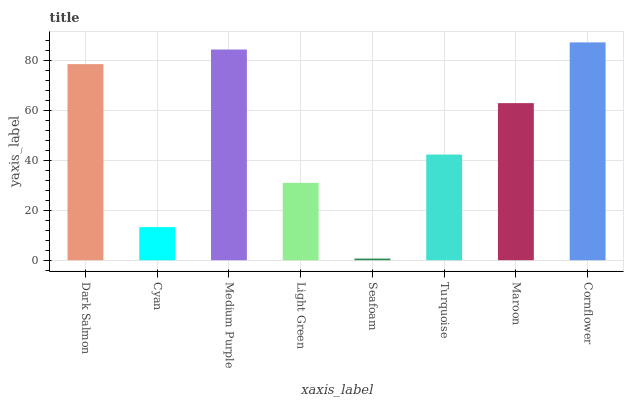Is Seafoam the minimum?
Answer yes or no. Yes. Is Cornflower the maximum?
Answer yes or no. Yes. Is Cyan the minimum?
Answer yes or no. No. Is Cyan the maximum?
Answer yes or no. No. Is Dark Salmon greater than Cyan?
Answer yes or no. Yes. Is Cyan less than Dark Salmon?
Answer yes or no. Yes. Is Cyan greater than Dark Salmon?
Answer yes or no. No. Is Dark Salmon less than Cyan?
Answer yes or no. No. Is Maroon the high median?
Answer yes or no. Yes. Is Turquoise the low median?
Answer yes or no. Yes. Is Medium Purple the high median?
Answer yes or no. No. Is Cyan the low median?
Answer yes or no. No. 